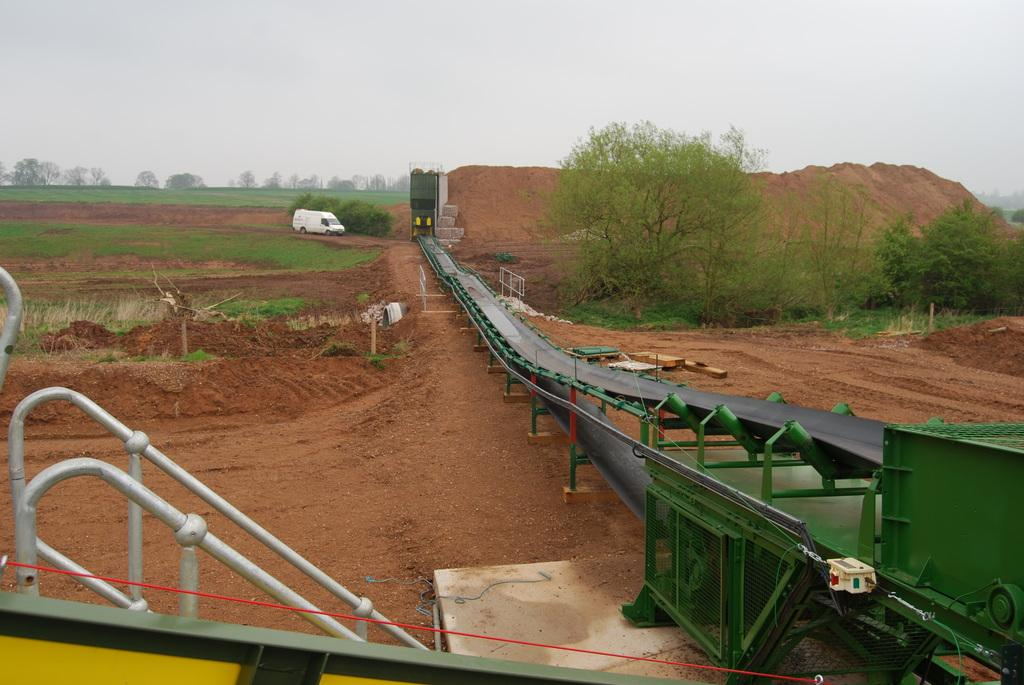What type of terrain is visible in the image? There is grass on the ground in the image. What natural elements are present in the image? There are trees in the image. What man-made objects can be seen in the image? There is a vehicle and a machine in the image. How would you describe the weather in the image? The sky is cloudy in the image. What type of competition is taking place in the image? There is no competition present in the image. Can you see a ball being used in the image? There is no ball visible in the image. 